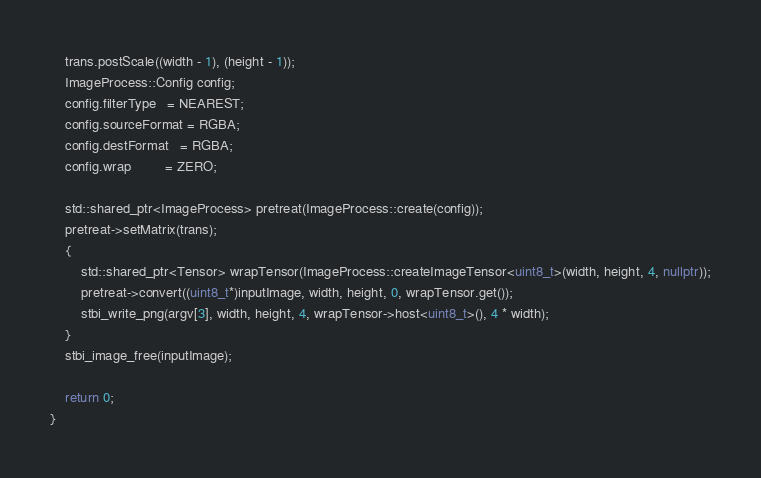Convert code to text. <code><loc_0><loc_0><loc_500><loc_500><_C++_>    trans.postScale((width - 1), (height - 1));
    ImageProcess::Config config;
    config.filterType   = NEAREST;
    config.sourceFormat = RGBA;
    config.destFormat   = RGBA;
    config.wrap         = ZERO;

    std::shared_ptr<ImageProcess> pretreat(ImageProcess::create(config));
    pretreat->setMatrix(trans);
    {
        std::shared_ptr<Tensor> wrapTensor(ImageProcess::createImageTensor<uint8_t>(width, height, 4, nullptr));
        pretreat->convert((uint8_t*)inputImage, width, height, 0, wrapTensor.get());
        stbi_write_png(argv[3], width, height, 4, wrapTensor->host<uint8_t>(), 4 * width);
    }
    stbi_image_free(inputImage);

    return 0;
}
</code> 